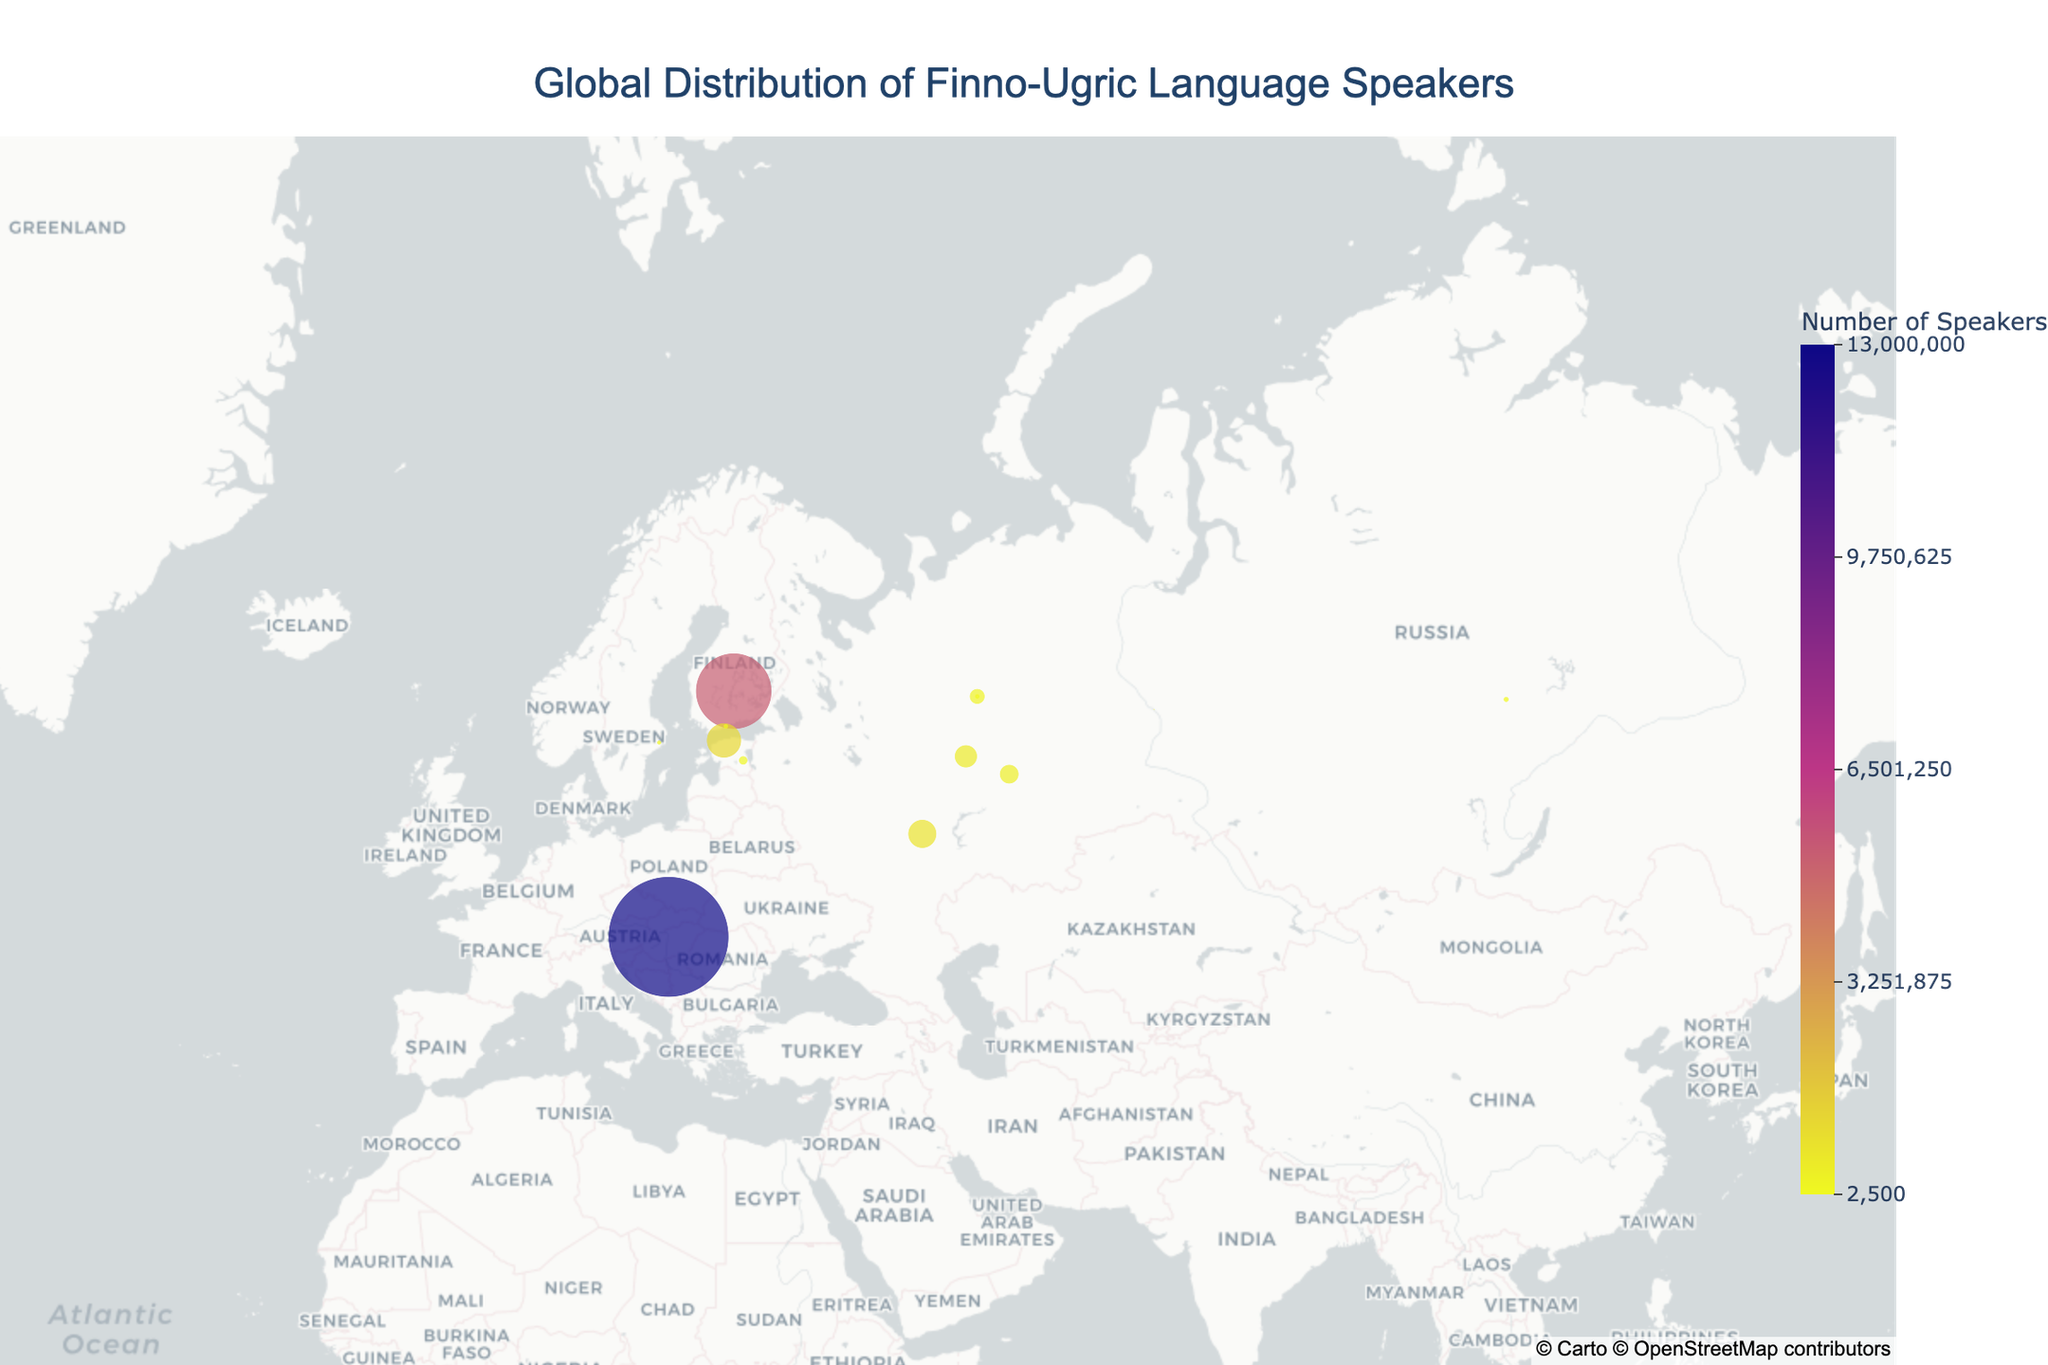Which country has the highest number of Finno-Ugric language speakers? The country with the highest number of Finno-Ugric language speakers can be identified by the largest circle in the figure. Hungary has the largest circle within its boundaries, representing 13,000,000 Hungarian speakers, which is the highest among the data provided.
Answer: Hungary Which countries have Finno-Ugric language speakers but less than 100,000? To determine which countries have less than 100,000 Finno-Ugric language speakers, we need to look at the smaller circles in the figure. The languages and corresponding speakers less than 100,000 are Khanty (31,000 in Russia), Mansi (2,500 in Russia), Sami (20,000 in Sweden, and 25,000 in Norway), Veps (3,600 in Russia), and Karelian (25,000 in Finland).
Answer: Russia, Sweden, Norway, Finland What is the total number of Finno-Ugric language speakers in Russia? To calculate the total number of Finno-Ugric language speakers in Russia, sum all the speakers for different languages in Russia: Khanty (31,000), Komi (220,000), Mari (475,000), Mordvin (744,000), Udmurt (340,000), Mansi (2,500), and Veps (3,600). 31,000 + 220,000 + 475,000 + 744,000 + 340,000 + 2,500 + 3,600 = 1,816,100. So, the total is 1,816,100.
Answer: 1,816,100 Which language has the smallest number of speakers, and where is it spoken? The smallest circle in the figure represents the language with the fewest speakers. Mansi has the smallest number of speakers (2,500), and it is spoken in Russia.
Answer: Mansi, Russia Between Finland and Estonia, which country has more Finno-Ugric language speakers, and by how much? Finnish speakers in Finland are 5,200,000, and Estonian speakers in Estonia are 1,100,000. Subtract the number of Estonian speakers from the number of Finnish speakers to find the difference: 5,200,000 - 1,100,000 = 4,100,000. Finland has 4,100,000 more Finno-Ugric language speakers than Estonia.
Answer: Finland by 4,100,000 Which language is spoken in multiple countries, and what are those countries? The language that appears in multiple locations on the map is the Sami language. The Sami language is spoken in both Norway and Sweden as indicated by circles in both countries.
Answer: Sami, Norway and Sweden 